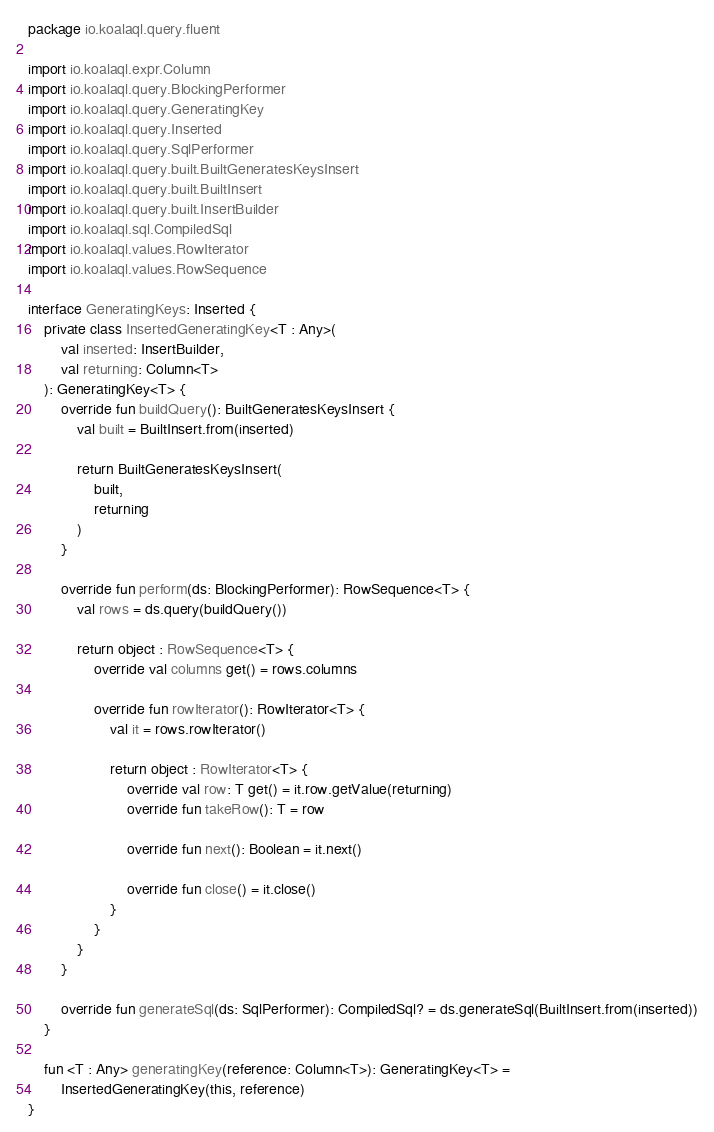Convert code to text. <code><loc_0><loc_0><loc_500><loc_500><_Kotlin_>package io.koalaql.query.fluent

import io.koalaql.expr.Column
import io.koalaql.query.BlockingPerformer
import io.koalaql.query.GeneratingKey
import io.koalaql.query.Inserted
import io.koalaql.query.SqlPerformer
import io.koalaql.query.built.BuiltGeneratesKeysInsert
import io.koalaql.query.built.BuiltInsert
import io.koalaql.query.built.InsertBuilder
import io.koalaql.sql.CompiledSql
import io.koalaql.values.RowIterator
import io.koalaql.values.RowSequence

interface GeneratingKeys: Inserted {
    private class InsertedGeneratingKey<T : Any>(
        val inserted: InsertBuilder,
        val returning: Column<T>
    ): GeneratingKey<T> {
        override fun buildQuery(): BuiltGeneratesKeysInsert {
            val built = BuiltInsert.from(inserted)

            return BuiltGeneratesKeysInsert(
                built,
                returning
            )
        }

        override fun perform(ds: BlockingPerformer): RowSequence<T> {
            val rows = ds.query(buildQuery())

            return object : RowSequence<T> {
                override val columns get() = rows.columns

                override fun rowIterator(): RowIterator<T> {
                    val it = rows.rowIterator()

                    return object : RowIterator<T> {
                        override val row: T get() = it.row.getValue(returning)
                        override fun takeRow(): T = row

                        override fun next(): Boolean = it.next()

                        override fun close() = it.close()
                    }
                }
            }
        }

        override fun generateSql(ds: SqlPerformer): CompiledSql? = ds.generateSql(BuiltInsert.from(inserted))
    }

    fun <T : Any> generatingKey(reference: Column<T>): GeneratingKey<T> =
        InsertedGeneratingKey(this, reference)
}</code> 